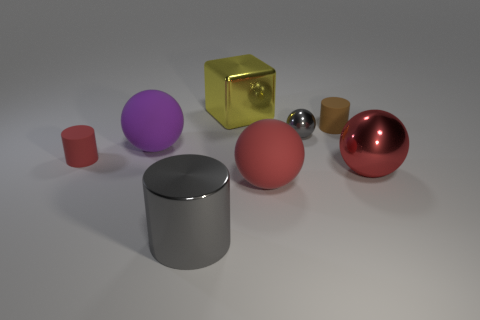Is there a large object of the same color as the tiny shiny thing?
Your response must be concise. Yes. Does the large matte object to the right of the big yellow object have the same shape as the gray metal object behind the purple ball?
Your response must be concise. Yes. Is there a purple sphere that has the same material as the gray cylinder?
Make the answer very short. No. What number of blue things are either small rubber cylinders or tiny metallic objects?
Provide a succinct answer. 0. What is the size of the cylinder that is both behind the shiny cylinder and to the right of the red rubber cylinder?
Offer a very short reply. Small. Is the number of rubber cylinders on the right side of the small metal ball greater than the number of tiny gray matte balls?
Offer a terse response. Yes. How many blocks are either matte things or small gray shiny objects?
Ensure brevity in your answer.  0. What is the shape of the big shiny thing that is on the left side of the big metal ball and in front of the small brown cylinder?
Provide a short and direct response. Cylinder. Are there an equal number of small balls that are to the left of the purple matte object and tiny matte cylinders in front of the tiny gray metal object?
Your answer should be compact. No. What number of things are either tiny brown cylinders or gray things?
Offer a terse response. 3. 